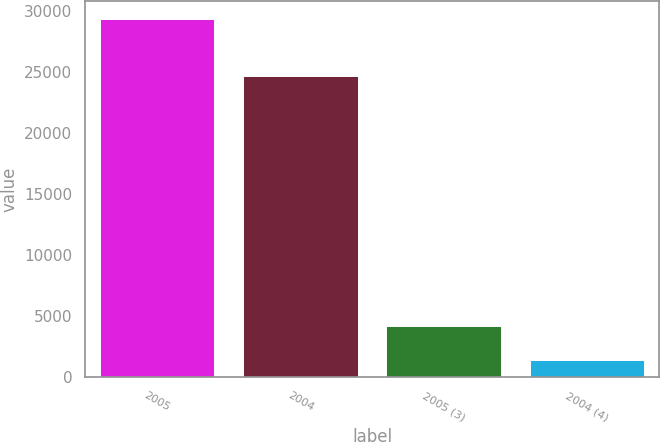<chart> <loc_0><loc_0><loc_500><loc_500><bar_chart><fcel>2005<fcel>2004<fcel>2005 (3)<fcel>2004 (4)<nl><fcel>29363<fcel>24710<fcel>4232.3<fcel>1440<nl></chart> 